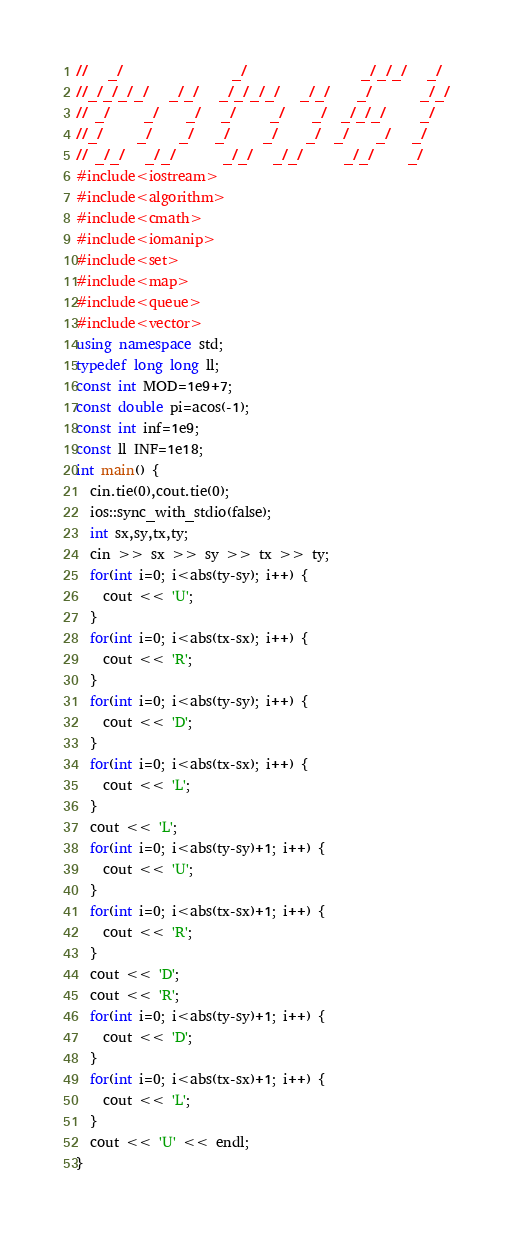Convert code to text. <code><loc_0><loc_0><loc_500><loc_500><_C++_>//   _/                _/                 _/_/_/   _/
//_/_/_/_/   _/_/   _/_/_/_/   _/_/    _/       _/_/
// _/     _/    _/   _/     _/    _/  _/_/_/     _/
//_/     _/    _/   _/     _/    _/  _/    _/   _/
// _/_/   _/_/       _/_/   _/_/      _/_/     _/
#include<iostream>
#include<algorithm>
#include<cmath>
#include<iomanip>
#include<set>
#include<map>
#include<queue>
#include<vector>
using namespace std;
typedef long long ll;
const int MOD=1e9+7;
const double pi=acos(-1);
const int inf=1e9;
const ll INF=1e18;
int main() {
  cin.tie(0),cout.tie(0);
  ios::sync_with_stdio(false);
  int sx,sy,tx,ty;
  cin >> sx >> sy >> tx >> ty;
  for(int i=0; i<abs(ty-sy); i++) {
    cout << 'U';
  }
  for(int i=0; i<abs(tx-sx); i++) {
    cout << 'R';
  }
  for(int i=0; i<abs(ty-sy); i++) {
    cout << 'D';
  }
  for(int i=0; i<abs(tx-sx); i++) {
    cout << 'L';
  }
  cout << 'L';
  for(int i=0; i<abs(ty-sy)+1; i++) {
    cout << 'U';
  }
  for(int i=0; i<abs(tx-sx)+1; i++) {
    cout << 'R';
  }
  cout << 'D';
  cout << 'R';
  for(int i=0; i<abs(ty-sy)+1; i++) {
    cout << 'D';
  }
  for(int i=0; i<abs(tx-sx)+1; i++) {
    cout << 'L';
  }
  cout << 'U' << endl;
}
</code> 